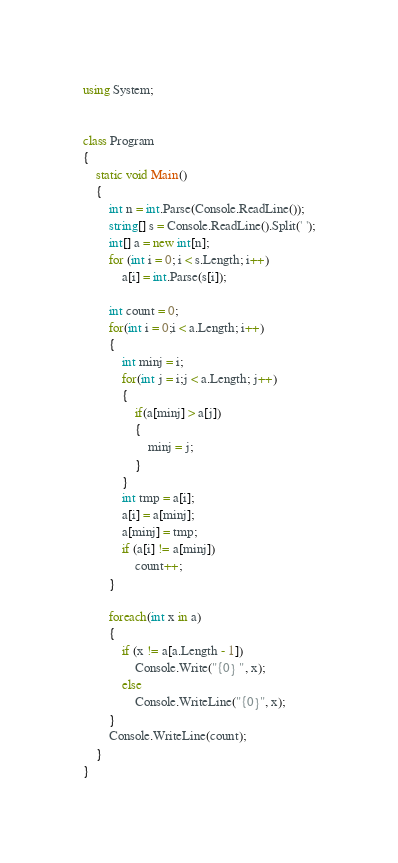<code> <loc_0><loc_0><loc_500><loc_500><_C#_>using System;


class Program
{
    static void Main()
    {
        int n = int.Parse(Console.ReadLine());
        string[] s = Console.ReadLine().Split(' ');
        int[] a = new int[n];
        for (int i = 0; i < s.Length; i++)
            a[i] = int.Parse(s[i]);

        int count = 0;
        for(int i = 0;i < a.Length; i++)
        {
            int minj = i;
            for(int j = i;j < a.Length; j++)
            {
                if(a[minj] > a[j])
                {
                    minj = j;
                }
            }
            int tmp = a[i];
            a[i] = a[minj];
            a[minj] = tmp;
            if (a[i] != a[minj])
                count++;
        }

        foreach(int x in a)
        {
            if (x != a[a.Length - 1])
                Console.Write("{0} ", x);
            else
                Console.WriteLine("{0}", x);
        }
        Console.WriteLine(count);
    }
}</code> 